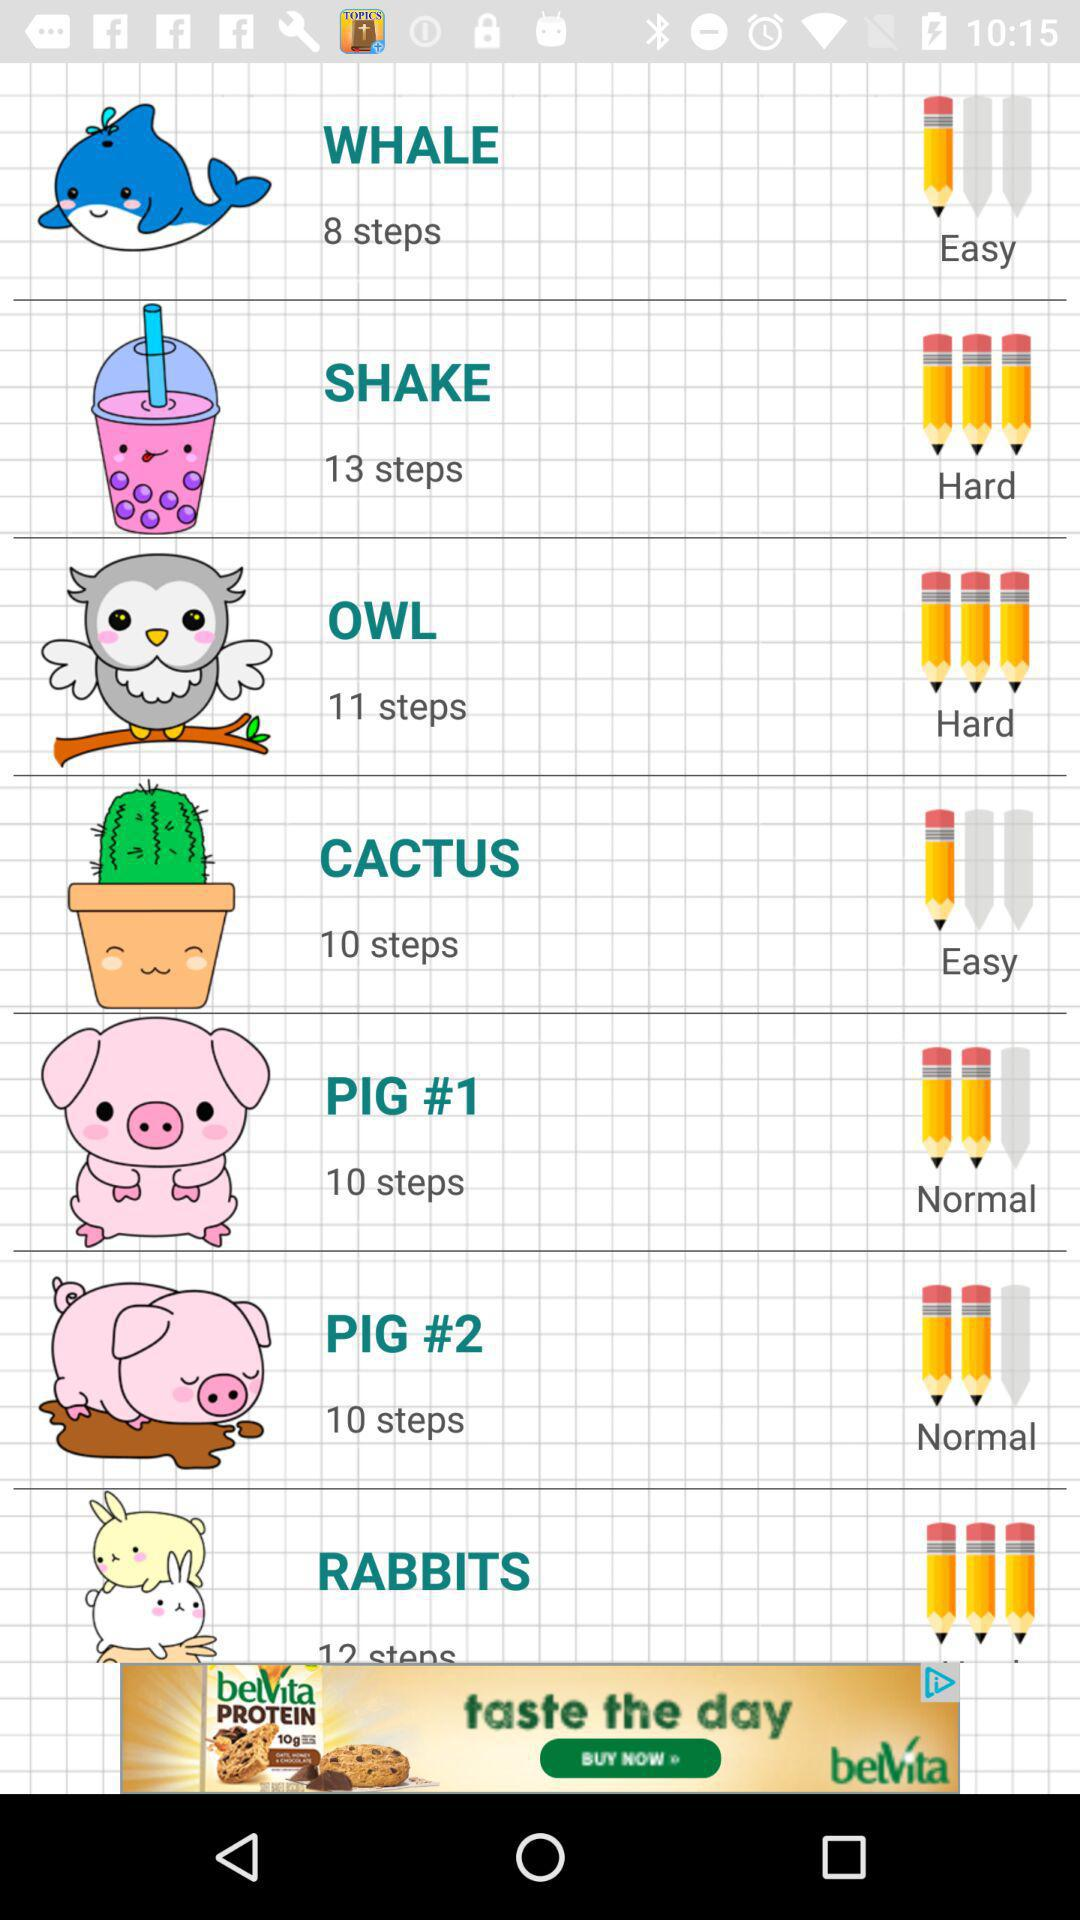How many steps are in "SHAKE"? There are 13 steps in "SHAKE". 